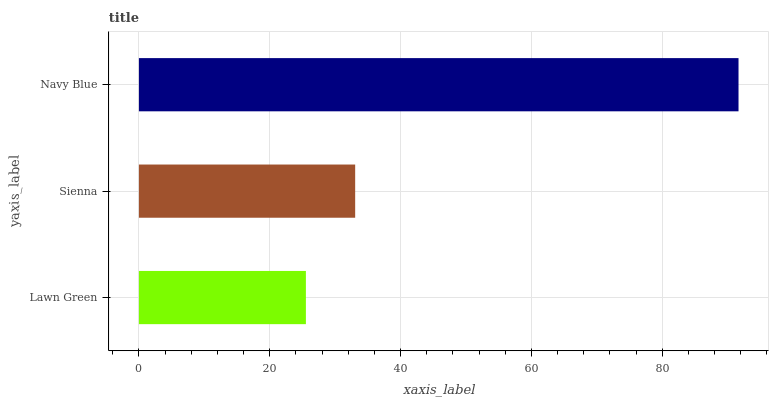Is Lawn Green the minimum?
Answer yes or no. Yes. Is Navy Blue the maximum?
Answer yes or no. Yes. Is Sienna the minimum?
Answer yes or no. No. Is Sienna the maximum?
Answer yes or no. No. Is Sienna greater than Lawn Green?
Answer yes or no. Yes. Is Lawn Green less than Sienna?
Answer yes or no. Yes. Is Lawn Green greater than Sienna?
Answer yes or no. No. Is Sienna less than Lawn Green?
Answer yes or no. No. Is Sienna the high median?
Answer yes or no. Yes. Is Sienna the low median?
Answer yes or no. Yes. Is Navy Blue the high median?
Answer yes or no. No. Is Navy Blue the low median?
Answer yes or no. No. 